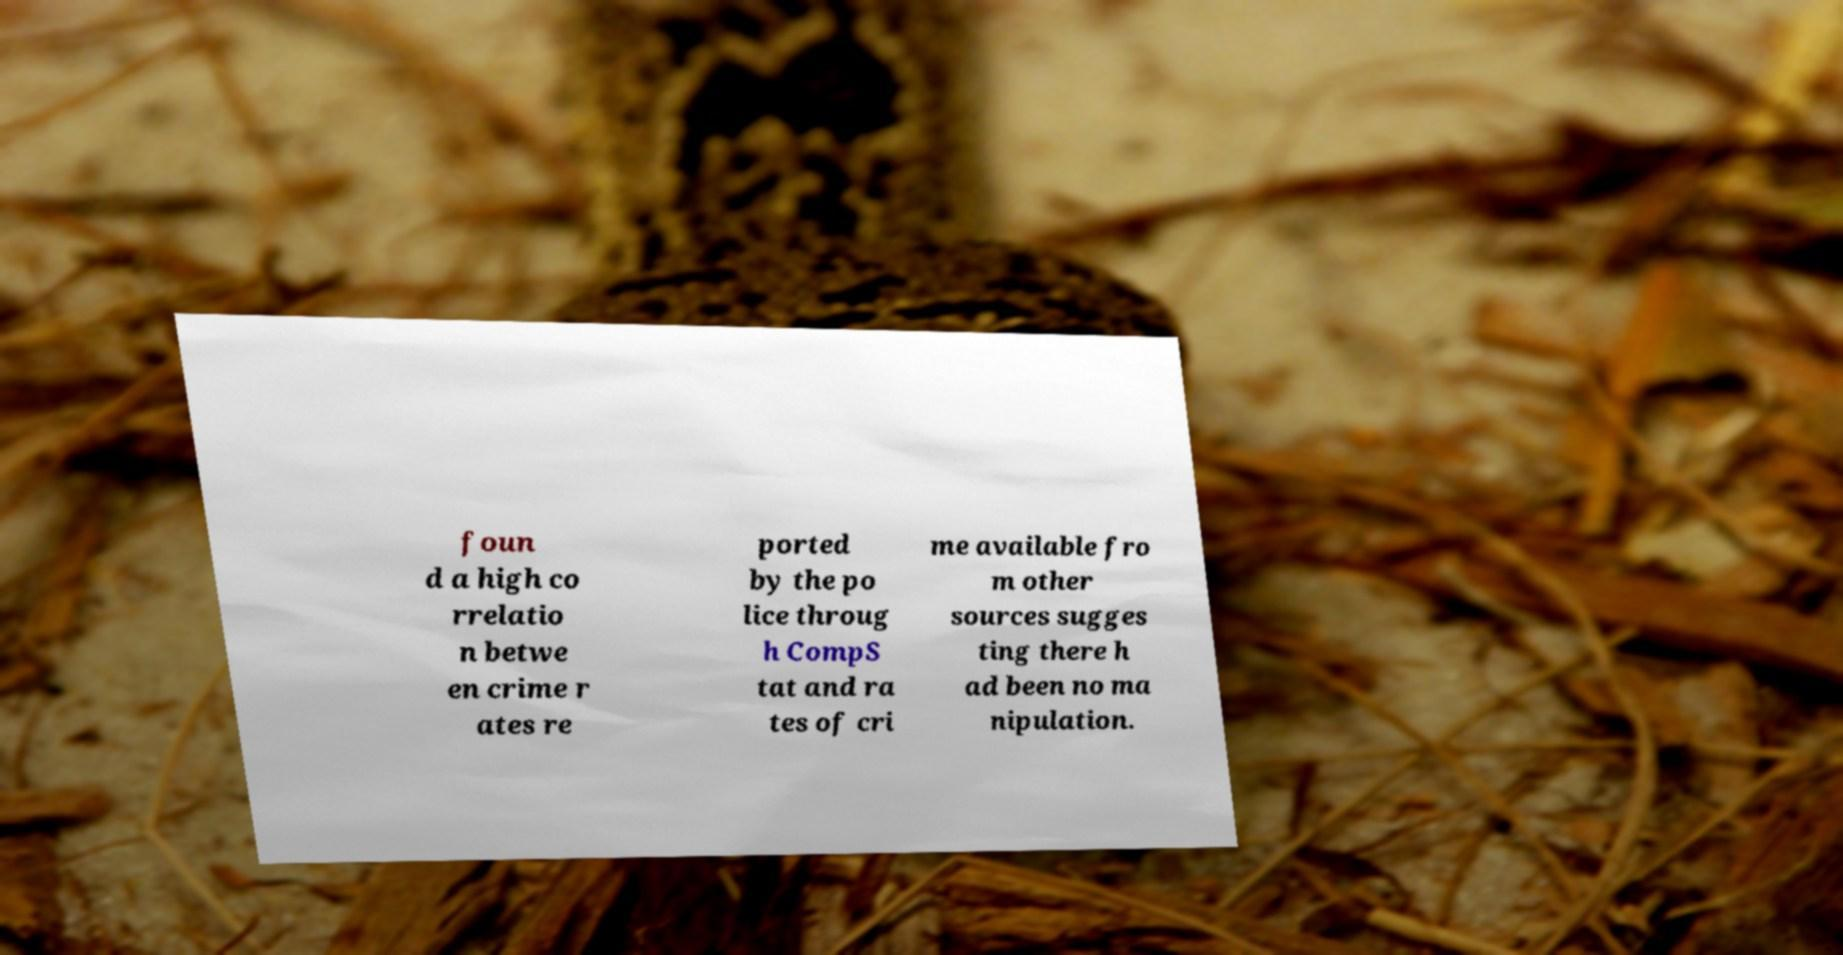There's text embedded in this image that I need extracted. Can you transcribe it verbatim? foun d a high co rrelatio n betwe en crime r ates re ported by the po lice throug h CompS tat and ra tes of cri me available fro m other sources sugges ting there h ad been no ma nipulation. 